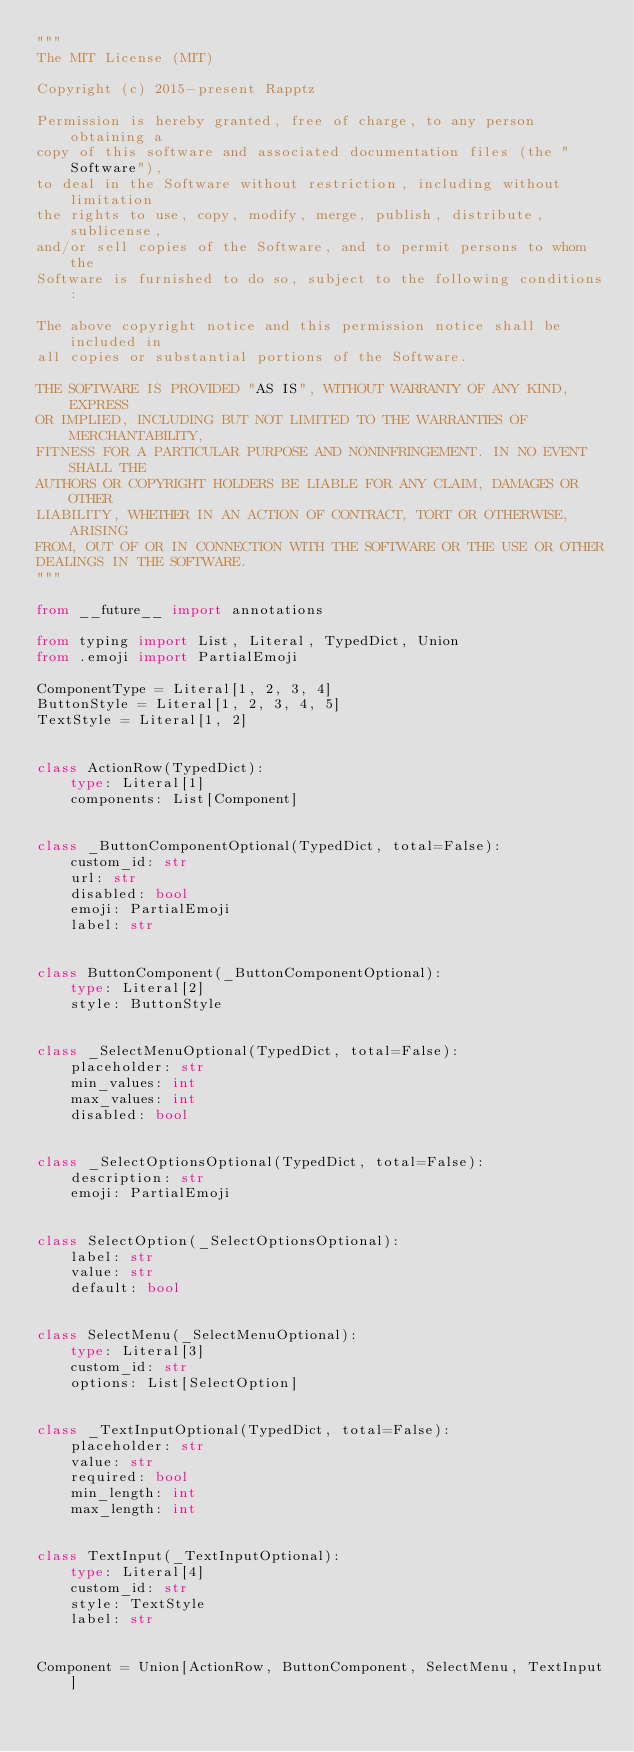<code> <loc_0><loc_0><loc_500><loc_500><_Python_>"""
The MIT License (MIT)

Copyright (c) 2015-present Rapptz

Permission is hereby granted, free of charge, to any person obtaining a
copy of this software and associated documentation files (the "Software"),
to deal in the Software without restriction, including without limitation
the rights to use, copy, modify, merge, publish, distribute, sublicense,
and/or sell copies of the Software, and to permit persons to whom the
Software is furnished to do so, subject to the following conditions:

The above copyright notice and this permission notice shall be included in
all copies or substantial portions of the Software.

THE SOFTWARE IS PROVIDED "AS IS", WITHOUT WARRANTY OF ANY KIND, EXPRESS
OR IMPLIED, INCLUDING BUT NOT LIMITED TO THE WARRANTIES OF MERCHANTABILITY,
FITNESS FOR A PARTICULAR PURPOSE AND NONINFRINGEMENT. IN NO EVENT SHALL THE
AUTHORS OR COPYRIGHT HOLDERS BE LIABLE FOR ANY CLAIM, DAMAGES OR OTHER
LIABILITY, WHETHER IN AN ACTION OF CONTRACT, TORT OR OTHERWISE, ARISING
FROM, OUT OF OR IN CONNECTION WITH THE SOFTWARE OR THE USE OR OTHER
DEALINGS IN THE SOFTWARE.
"""

from __future__ import annotations

from typing import List, Literal, TypedDict, Union
from .emoji import PartialEmoji

ComponentType = Literal[1, 2, 3, 4]
ButtonStyle = Literal[1, 2, 3, 4, 5]
TextStyle = Literal[1, 2]


class ActionRow(TypedDict):
    type: Literal[1]
    components: List[Component]


class _ButtonComponentOptional(TypedDict, total=False):
    custom_id: str
    url: str
    disabled: bool
    emoji: PartialEmoji
    label: str


class ButtonComponent(_ButtonComponentOptional):
    type: Literal[2]
    style: ButtonStyle


class _SelectMenuOptional(TypedDict, total=False):
    placeholder: str
    min_values: int
    max_values: int
    disabled: bool


class _SelectOptionsOptional(TypedDict, total=False):
    description: str
    emoji: PartialEmoji


class SelectOption(_SelectOptionsOptional):
    label: str
    value: str
    default: bool


class SelectMenu(_SelectMenuOptional):
    type: Literal[3]
    custom_id: str
    options: List[SelectOption]


class _TextInputOptional(TypedDict, total=False):
    placeholder: str
    value: str
    required: bool
    min_length: int
    max_length: int


class TextInput(_TextInputOptional):
    type: Literal[4]
    custom_id: str
    style: TextStyle
    label: str


Component = Union[ActionRow, ButtonComponent, SelectMenu, TextInput]
</code> 